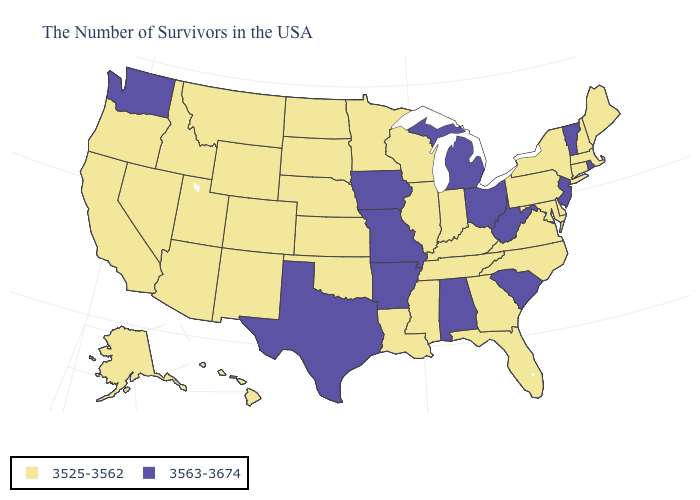What is the lowest value in the South?
Concise answer only. 3525-3562. What is the value of West Virginia?
Write a very short answer. 3563-3674. What is the highest value in the USA?
Short answer required. 3563-3674. Name the states that have a value in the range 3525-3562?
Concise answer only. Maine, Massachusetts, New Hampshire, Connecticut, New York, Delaware, Maryland, Pennsylvania, Virginia, North Carolina, Florida, Georgia, Kentucky, Indiana, Tennessee, Wisconsin, Illinois, Mississippi, Louisiana, Minnesota, Kansas, Nebraska, Oklahoma, South Dakota, North Dakota, Wyoming, Colorado, New Mexico, Utah, Montana, Arizona, Idaho, Nevada, California, Oregon, Alaska, Hawaii. Does New Mexico have the highest value in the USA?
Answer briefly. No. Name the states that have a value in the range 3563-3674?
Short answer required. Rhode Island, Vermont, New Jersey, South Carolina, West Virginia, Ohio, Michigan, Alabama, Missouri, Arkansas, Iowa, Texas, Washington. Among the states that border Nebraska , does Iowa have the highest value?
Give a very brief answer. Yes. Name the states that have a value in the range 3525-3562?
Quick response, please. Maine, Massachusetts, New Hampshire, Connecticut, New York, Delaware, Maryland, Pennsylvania, Virginia, North Carolina, Florida, Georgia, Kentucky, Indiana, Tennessee, Wisconsin, Illinois, Mississippi, Louisiana, Minnesota, Kansas, Nebraska, Oklahoma, South Dakota, North Dakota, Wyoming, Colorado, New Mexico, Utah, Montana, Arizona, Idaho, Nevada, California, Oregon, Alaska, Hawaii. Among the states that border Mississippi , which have the lowest value?
Concise answer only. Tennessee, Louisiana. What is the value of Idaho?
Answer briefly. 3525-3562. Which states hav the highest value in the West?
Be succinct. Washington. Which states have the highest value in the USA?
Short answer required. Rhode Island, Vermont, New Jersey, South Carolina, West Virginia, Ohio, Michigan, Alabama, Missouri, Arkansas, Iowa, Texas, Washington. Does Florida have the highest value in the South?
Be succinct. No. Among the states that border Utah , which have the highest value?
Concise answer only. Wyoming, Colorado, New Mexico, Arizona, Idaho, Nevada. 